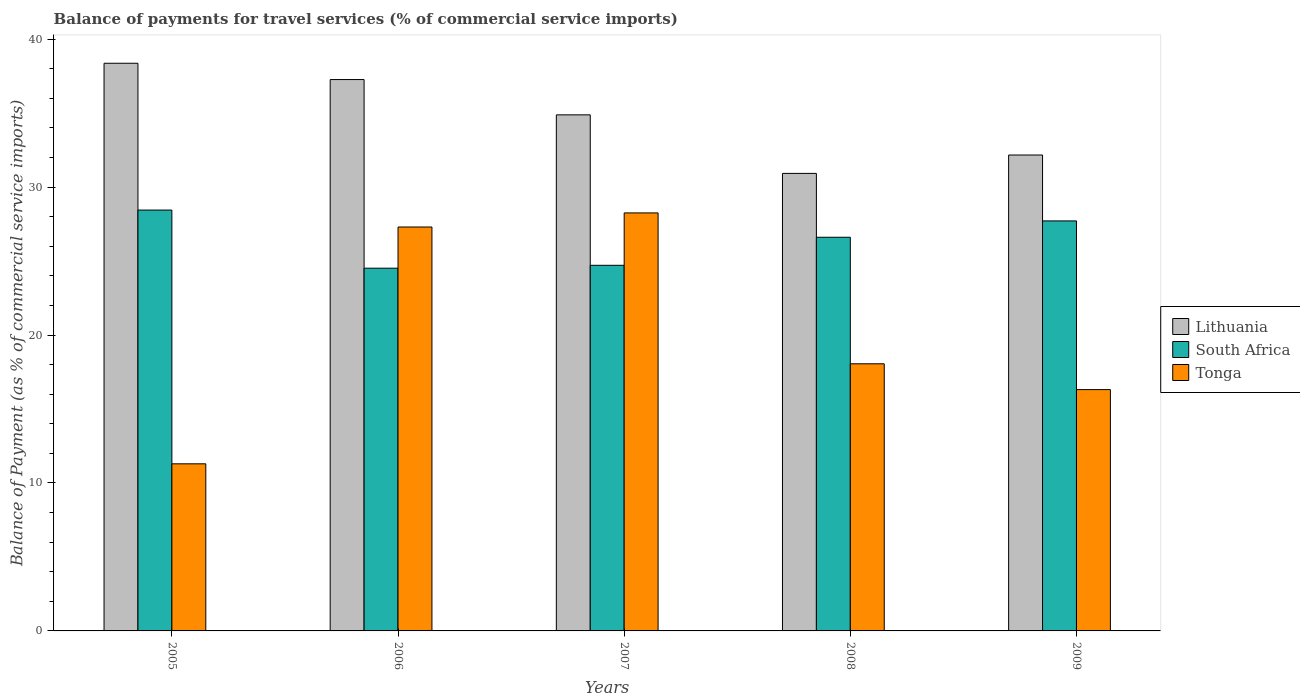How many different coloured bars are there?
Offer a very short reply. 3. How many groups of bars are there?
Make the answer very short. 5. How many bars are there on the 1st tick from the left?
Your response must be concise. 3. How many bars are there on the 4th tick from the right?
Your answer should be very brief. 3. What is the label of the 1st group of bars from the left?
Make the answer very short. 2005. In how many cases, is the number of bars for a given year not equal to the number of legend labels?
Make the answer very short. 0. What is the balance of payments for travel services in South Africa in 2005?
Offer a terse response. 28.45. Across all years, what is the maximum balance of payments for travel services in South Africa?
Offer a terse response. 28.45. Across all years, what is the minimum balance of payments for travel services in Lithuania?
Keep it short and to the point. 30.93. What is the total balance of payments for travel services in Lithuania in the graph?
Offer a terse response. 173.62. What is the difference between the balance of payments for travel services in Tonga in 2006 and that in 2008?
Your response must be concise. 9.25. What is the difference between the balance of payments for travel services in Lithuania in 2008 and the balance of payments for travel services in South Africa in 2005?
Offer a terse response. 2.48. What is the average balance of payments for travel services in Lithuania per year?
Provide a succinct answer. 34.72. In the year 2005, what is the difference between the balance of payments for travel services in South Africa and balance of payments for travel services in Lithuania?
Give a very brief answer. -9.92. In how many years, is the balance of payments for travel services in South Africa greater than 24 %?
Give a very brief answer. 5. What is the ratio of the balance of payments for travel services in Lithuania in 2005 to that in 2009?
Ensure brevity in your answer.  1.19. Is the balance of payments for travel services in Tonga in 2006 less than that in 2009?
Offer a very short reply. No. Is the difference between the balance of payments for travel services in South Africa in 2006 and 2007 greater than the difference between the balance of payments for travel services in Lithuania in 2006 and 2007?
Your answer should be very brief. No. What is the difference between the highest and the second highest balance of payments for travel services in Lithuania?
Give a very brief answer. 1.1. What is the difference between the highest and the lowest balance of payments for travel services in Tonga?
Your answer should be compact. 16.96. What does the 3rd bar from the left in 2008 represents?
Your answer should be very brief. Tonga. What does the 3rd bar from the right in 2009 represents?
Ensure brevity in your answer.  Lithuania. What is the difference between two consecutive major ticks on the Y-axis?
Your answer should be very brief. 10. What is the title of the graph?
Make the answer very short. Balance of payments for travel services (% of commercial service imports). Does "Saudi Arabia" appear as one of the legend labels in the graph?
Ensure brevity in your answer.  No. What is the label or title of the X-axis?
Give a very brief answer. Years. What is the label or title of the Y-axis?
Your answer should be very brief. Balance of Payment (as % of commercial service imports). What is the Balance of Payment (as % of commercial service imports) in Lithuania in 2005?
Keep it short and to the point. 38.37. What is the Balance of Payment (as % of commercial service imports) in South Africa in 2005?
Provide a short and direct response. 28.45. What is the Balance of Payment (as % of commercial service imports) in Tonga in 2005?
Your response must be concise. 11.29. What is the Balance of Payment (as % of commercial service imports) of Lithuania in 2006?
Offer a terse response. 37.27. What is the Balance of Payment (as % of commercial service imports) in South Africa in 2006?
Provide a succinct answer. 24.52. What is the Balance of Payment (as % of commercial service imports) in Tonga in 2006?
Make the answer very short. 27.3. What is the Balance of Payment (as % of commercial service imports) of Lithuania in 2007?
Offer a terse response. 34.88. What is the Balance of Payment (as % of commercial service imports) in South Africa in 2007?
Offer a terse response. 24.71. What is the Balance of Payment (as % of commercial service imports) in Tonga in 2007?
Give a very brief answer. 28.25. What is the Balance of Payment (as % of commercial service imports) in Lithuania in 2008?
Ensure brevity in your answer.  30.93. What is the Balance of Payment (as % of commercial service imports) in South Africa in 2008?
Provide a short and direct response. 26.61. What is the Balance of Payment (as % of commercial service imports) of Tonga in 2008?
Your answer should be very brief. 18.06. What is the Balance of Payment (as % of commercial service imports) of Lithuania in 2009?
Give a very brief answer. 32.17. What is the Balance of Payment (as % of commercial service imports) of South Africa in 2009?
Give a very brief answer. 27.71. What is the Balance of Payment (as % of commercial service imports) in Tonga in 2009?
Give a very brief answer. 16.31. Across all years, what is the maximum Balance of Payment (as % of commercial service imports) in Lithuania?
Offer a very short reply. 38.37. Across all years, what is the maximum Balance of Payment (as % of commercial service imports) in South Africa?
Your answer should be compact. 28.45. Across all years, what is the maximum Balance of Payment (as % of commercial service imports) of Tonga?
Your answer should be very brief. 28.25. Across all years, what is the minimum Balance of Payment (as % of commercial service imports) in Lithuania?
Your answer should be compact. 30.93. Across all years, what is the minimum Balance of Payment (as % of commercial service imports) in South Africa?
Keep it short and to the point. 24.52. Across all years, what is the minimum Balance of Payment (as % of commercial service imports) in Tonga?
Your answer should be very brief. 11.29. What is the total Balance of Payment (as % of commercial service imports) in Lithuania in the graph?
Your response must be concise. 173.62. What is the total Balance of Payment (as % of commercial service imports) in South Africa in the graph?
Give a very brief answer. 132. What is the total Balance of Payment (as % of commercial service imports) in Tonga in the graph?
Offer a terse response. 101.22. What is the difference between the Balance of Payment (as % of commercial service imports) in Lithuania in 2005 and that in 2006?
Your answer should be compact. 1.1. What is the difference between the Balance of Payment (as % of commercial service imports) in South Africa in 2005 and that in 2006?
Keep it short and to the point. 3.93. What is the difference between the Balance of Payment (as % of commercial service imports) of Tonga in 2005 and that in 2006?
Provide a short and direct response. -16.01. What is the difference between the Balance of Payment (as % of commercial service imports) in Lithuania in 2005 and that in 2007?
Offer a terse response. 3.49. What is the difference between the Balance of Payment (as % of commercial service imports) of South Africa in 2005 and that in 2007?
Provide a short and direct response. 3.73. What is the difference between the Balance of Payment (as % of commercial service imports) in Tonga in 2005 and that in 2007?
Provide a succinct answer. -16.96. What is the difference between the Balance of Payment (as % of commercial service imports) of Lithuania in 2005 and that in 2008?
Ensure brevity in your answer.  7.44. What is the difference between the Balance of Payment (as % of commercial service imports) of South Africa in 2005 and that in 2008?
Offer a terse response. 1.84. What is the difference between the Balance of Payment (as % of commercial service imports) in Tonga in 2005 and that in 2008?
Offer a terse response. -6.76. What is the difference between the Balance of Payment (as % of commercial service imports) of Lithuania in 2005 and that in 2009?
Offer a terse response. 6.2. What is the difference between the Balance of Payment (as % of commercial service imports) in South Africa in 2005 and that in 2009?
Provide a succinct answer. 0.73. What is the difference between the Balance of Payment (as % of commercial service imports) of Tonga in 2005 and that in 2009?
Provide a short and direct response. -5.02. What is the difference between the Balance of Payment (as % of commercial service imports) of Lithuania in 2006 and that in 2007?
Offer a very short reply. 2.39. What is the difference between the Balance of Payment (as % of commercial service imports) of South Africa in 2006 and that in 2007?
Provide a short and direct response. -0.2. What is the difference between the Balance of Payment (as % of commercial service imports) of Tonga in 2006 and that in 2007?
Provide a succinct answer. -0.95. What is the difference between the Balance of Payment (as % of commercial service imports) of Lithuania in 2006 and that in 2008?
Provide a short and direct response. 6.34. What is the difference between the Balance of Payment (as % of commercial service imports) in South Africa in 2006 and that in 2008?
Provide a short and direct response. -2.09. What is the difference between the Balance of Payment (as % of commercial service imports) of Tonga in 2006 and that in 2008?
Your answer should be compact. 9.25. What is the difference between the Balance of Payment (as % of commercial service imports) of Lithuania in 2006 and that in 2009?
Make the answer very short. 5.1. What is the difference between the Balance of Payment (as % of commercial service imports) in South Africa in 2006 and that in 2009?
Your answer should be very brief. -3.2. What is the difference between the Balance of Payment (as % of commercial service imports) of Tonga in 2006 and that in 2009?
Offer a very short reply. 10.99. What is the difference between the Balance of Payment (as % of commercial service imports) in Lithuania in 2007 and that in 2008?
Make the answer very short. 3.96. What is the difference between the Balance of Payment (as % of commercial service imports) of South Africa in 2007 and that in 2008?
Your response must be concise. -1.9. What is the difference between the Balance of Payment (as % of commercial service imports) in Tonga in 2007 and that in 2008?
Offer a very short reply. 10.2. What is the difference between the Balance of Payment (as % of commercial service imports) in Lithuania in 2007 and that in 2009?
Give a very brief answer. 2.71. What is the difference between the Balance of Payment (as % of commercial service imports) of South Africa in 2007 and that in 2009?
Offer a terse response. -3. What is the difference between the Balance of Payment (as % of commercial service imports) of Tonga in 2007 and that in 2009?
Your answer should be compact. 11.94. What is the difference between the Balance of Payment (as % of commercial service imports) of Lithuania in 2008 and that in 2009?
Provide a succinct answer. -1.24. What is the difference between the Balance of Payment (as % of commercial service imports) in South Africa in 2008 and that in 2009?
Provide a succinct answer. -1.1. What is the difference between the Balance of Payment (as % of commercial service imports) in Tonga in 2008 and that in 2009?
Give a very brief answer. 1.74. What is the difference between the Balance of Payment (as % of commercial service imports) of Lithuania in 2005 and the Balance of Payment (as % of commercial service imports) of South Africa in 2006?
Make the answer very short. 13.85. What is the difference between the Balance of Payment (as % of commercial service imports) of Lithuania in 2005 and the Balance of Payment (as % of commercial service imports) of Tonga in 2006?
Your answer should be very brief. 11.07. What is the difference between the Balance of Payment (as % of commercial service imports) of South Africa in 2005 and the Balance of Payment (as % of commercial service imports) of Tonga in 2006?
Offer a very short reply. 1.15. What is the difference between the Balance of Payment (as % of commercial service imports) in Lithuania in 2005 and the Balance of Payment (as % of commercial service imports) in South Africa in 2007?
Make the answer very short. 13.66. What is the difference between the Balance of Payment (as % of commercial service imports) of Lithuania in 2005 and the Balance of Payment (as % of commercial service imports) of Tonga in 2007?
Offer a terse response. 10.12. What is the difference between the Balance of Payment (as % of commercial service imports) in South Africa in 2005 and the Balance of Payment (as % of commercial service imports) in Tonga in 2007?
Offer a terse response. 0.19. What is the difference between the Balance of Payment (as % of commercial service imports) in Lithuania in 2005 and the Balance of Payment (as % of commercial service imports) in South Africa in 2008?
Ensure brevity in your answer.  11.76. What is the difference between the Balance of Payment (as % of commercial service imports) of Lithuania in 2005 and the Balance of Payment (as % of commercial service imports) of Tonga in 2008?
Ensure brevity in your answer.  20.31. What is the difference between the Balance of Payment (as % of commercial service imports) of South Africa in 2005 and the Balance of Payment (as % of commercial service imports) of Tonga in 2008?
Offer a terse response. 10.39. What is the difference between the Balance of Payment (as % of commercial service imports) in Lithuania in 2005 and the Balance of Payment (as % of commercial service imports) in South Africa in 2009?
Give a very brief answer. 10.66. What is the difference between the Balance of Payment (as % of commercial service imports) in Lithuania in 2005 and the Balance of Payment (as % of commercial service imports) in Tonga in 2009?
Make the answer very short. 22.06. What is the difference between the Balance of Payment (as % of commercial service imports) in South Africa in 2005 and the Balance of Payment (as % of commercial service imports) in Tonga in 2009?
Ensure brevity in your answer.  12.14. What is the difference between the Balance of Payment (as % of commercial service imports) in Lithuania in 2006 and the Balance of Payment (as % of commercial service imports) in South Africa in 2007?
Your response must be concise. 12.56. What is the difference between the Balance of Payment (as % of commercial service imports) of Lithuania in 2006 and the Balance of Payment (as % of commercial service imports) of Tonga in 2007?
Ensure brevity in your answer.  9.01. What is the difference between the Balance of Payment (as % of commercial service imports) in South Africa in 2006 and the Balance of Payment (as % of commercial service imports) in Tonga in 2007?
Keep it short and to the point. -3.74. What is the difference between the Balance of Payment (as % of commercial service imports) of Lithuania in 2006 and the Balance of Payment (as % of commercial service imports) of South Africa in 2008?
Offer a very short reply. 10.66. What is the difference between the Balance of Payment (as % of commercial service imports) in Lithuania in 2006 and the Balance of Payment (as % of commercial service imports) in Tonga in 2008?
Give a very brief answer. 19.21. What is the difference between the Balance of Payment (as % of commercial service imports) of South Africa in 2006 and the Balance of Payment (as % of commercial service imports) of Tonga in 2008?
Offer a terse response. 6.46. What is the difference between the Balance of Payment (as % of commercial service imports) of Lithuania in 2006 and the Balance of Payment (as % of commercial service imports) of South Africa in 2009?
Ensure brevity in your answer.  9.56. What is the difference between the Balance of Payment (as % of commercial service imports) in Lithuania in 2006 and the Balance of Payment (as % of commercial service imports) in Tonga in 2009?
Offer a very short reply. 20.96. What is the difference between the Balance of Payment (as % of commercial service imports) of South Africa in 2006 and the Balance of Payment (as % of commercial service imports) of Tonga in 2009?
Give a very brief answer. 8.21. What is the difference between the Balance of Payment (as % of commercial service imports) in Lithuania in 2007 and the Balance of Payment (as % of commercial service imports) in South Africa in 2008?
Your answer should be compact. 8.27. What is the difference between the Balance of Payment (as % of commercial service imports) in Lithuania in 2007 and the Balance of Payment (as % of commercial service imports) in Tonga in 2008?
Keep it short and to the point. 16.83. What is the difference between the Balance of Payment (as % of commercial service imports) in South Africa in 2007 and the Balance of Payment (as % of commercial service imports) in Tonga in 2008?
Make the answer very short. 6.66. What is the difference between the Balance of Payment (as % of commercial service imports) in Lithuania in 2007 and the Balance of Payment (as % of commercial service imports) in South Africa in 2009?
Offer a very short reply. 7.17. What is the difference between the Balance of Payment (as % of commercial service imports) in Lithuania in 2007 and the Balance of Payment (as % of commercial service imports) in Tonga in 2009?
Keep it short and to the point. 18.57. What is the difference between the Balance of Payment (as % of commercial service imports) in South Africa in 2007 and the Balance of Payment (as % of commercial service imports) in Tonga in 2009?
Give a very brief answer. 8.4. What is the difference between the Balance of Payment (as % of commercial service imports) in Lithuania in 2008 and the Balance of Payment (as % of commercial service imports) in South Africa in 2009?
Keep it short and to the point. 3.21. What is the difference between the Balance of Payment (as % of commercial service imports) of Lithuania in 2008 and the Balance of Payment (as % of commercial service imports) of Tonga in 2009?
Offer a very short reply. 14.61. What is the difference between the Balance of Payment (as % of commercial service imports) of South Africa in 2008 and the Balance of Payment (as % of commercial service imports) of Tonga in 2009?
Offer a very short reply. 10.3. What is the average Balance of Payment (as % of commercial service imports) of Lithuania per year?
Offer a terse response. 34.72. What is the average Balance of Payment (as % of commercial service imports) in South Africa per year?
Ensure brevity in your answer.  26.4. What is the average Balance of Payment (as % of commercial service imports) of Tonga per year?
Your answer should be compact. 20.24. In the year 2005, what is the difference between the Balance of Payment (as % of commercial service imports) in Lithuania and Balance of Payment (as % of commercial service imports) in South Africa?
Your answer should be very brief. 9.92. In the year 2005, what is the difference between the Balance of Payment (as % of commercial service imports) in Lithuania and Balance of Payment (as % of commercial service imports) in Tonga?
Ensure brevity in your answer.  27.08. In the year 2005, what is the difference between the Balance of Payment (as % of commercial service imports) in South Africa and Balance of Payment (as % of commercial service imports) in Tonga?
Your response must be concise. 17.15. In the year 2006, what is the difference between the Balance of Payment (as % of commercial service imports) of Lithuania and Balance of Payment (as % of commercial service imports) of South Africa?
Give a very brief answer. 12.75. In the year 2006, what is the difference between the Balance of Payment (as % of commercial service imports) in Lithuania and Balance of Payment (as % of commercial service imports) in Tonga?
Give a very brief answer. 9.97. In the year 2006, what is the difference between the Balance of Payment (as % of commercial service imports) in South Africa and Balance of Payment (as % of commercial service imports) in Tonga?
Provide a succinct answer. -2.78. In the year 2007, what is the difference between the Balance of Payment (as % of commercial service imports) in Lithuania and Balance of Payment (as % of commercial service imports) in South Africa?
Offer a very short reply. 10.17. In the year 2007, what is the difference between the Balance of Payment (as % of commercial service imports) in Lithuania and Balance of Payment (as % of commercial service imports) in Tonga?
Give a very brief answer. 6.63. In the year 2007, what is the difference between the Balance of Payment (as % of commercial service imports) in South Africa and Balance of Payment (as % of commercial service imports) in Tonga?
Ensure brevity in your answer.  -3.54. In the year 2008, what is the difference between the Balance of Payment (as % of commercial service imports) of Lithuania and Balance of Payment (as % of commercial service imports) of South Africa?
Your answer should be very brief. 4.32. In the year 2008, what is the difference between the Balance of Payment (as % of commercial service imports) of Lithuania and Balance of Payment (as % of commercial service imports) of Tonga?
Ensure brevity in your answer.  12.87. In the year 2008, what is the difference between the Balance of Payment (as % of commercial service imports) of South Africa and Balance of Payment (as % of commercial service imports) of Tonga?
Offer a terse response. 8.55. In the year 2009, what is the difference between the Balance of Payment (as % of commercial service imports) of Lithuania and Balance of Payment (as % of commercial service imports) of South Africa?
Your answer should be very brief. 4.45. In the year 2009, what is the difference between the Balance of Payment (as % of commercial service imports) in Lithuania and Balance of Payment (as % of commercial service imports) in Tonga?
Your answer should be very brief. 15.86. In the year 2009, what is the difference between the Balance of Payment (as % of commercial service imports) in South Africa and Balance of Payment (as % of commercial service imports) in Tonga?
Give a very brief answer. 11.4. What is the ratio of the Balance of Payment (as % of commercial service imports) of Lithuania in 2005 to that in 2006?
Keep it short and to the point. 1.03. What is the ratio of the Balance of Payment (as % of commercial service imports) of South Africa in 2005 to that in 2006?
Your answer should be compact. 1.16. What is the ratio of the Balance of Payment (as % of commercial service imports) of Tonga in 2005 to that in 2006?
Your answer should be compact. 0.41. What is the ratio of the Balance of Payment (as % of commercial service imports) of Lithuania in 2005 to that in 2007?
Your response must be concise. 1.1. What is the ratio of the Balance of Payment (as % of commercial service imports) of South Africa in 2005 to that in 2007?
Your answer should be compact. 1.15. What is the ratio of the Balance of Payment (as % of commercial service imports) of Tonga in 2005 to that in 2007?
Your answer should be compact. 0.4. What is the ratio of the Balance of Payment (as % of commercial service imports) in Lithuania in 2005 to that in 2008?
Your response must be concise. 1.24. What is the ratio of the Balance of Payment (as % of commercial service imports) in South Africa in 2005 to that in 2008?
Your response must be concise. 1.07. What is the ratio of the Balance of Payment (as % of commercial service imports) of Tonga in 2005 to that in 2008?
Provide a succinct answer. 0.63. What is the ratio of the Balance of Payment (as % of commercial service imports) of Lithuania in 2005 to that in 2009?
Your answer should be very brief. 1.19. What is the ratio of the Balance of Payment (as % of commercial service imports) in South Africa in 2005 to that in 2009?
Keep it short and to the point. 1.03. What is the ratio of the Balance of Payment (as % of commercial service imports) in Tonga in 2005 to that in 2009?
Make the answer very short. 0.69. What is the ratio of the Balance of Payment (as % of commercial service imports) in Lithuania in 2006 to that in 2007?
Your response must be concise. 1.07. What is the ratio of the Balance of Payment (as % of commercial service imports) of Tonga in 2006 to that in 2007?
Give a very brief answer. 0.97. What is the ratio of the Balance of Payment (as % of commercial service imports) of Lithuania in 2006 to that in 2008?
Provide a succinct answer. 1.21. What is the ratio of the Balance of Payment (as % of commercial service imports) in South Africa in 2006 to that in 2008?
Offer a terse response. 0.92. What is the ratio of the Balance of Payment (as % of commercial service imports) of Tonga in 2006 to that in 2008?
Provide a succinct answer. 1.51. What is the ratio of the Balance of Payment (as % of commercial service imports) of Lithuania in 2006 to that in 2009?
Keep it short and to the point. 1.16. What is the ratio of the Balance of Payment (as % of commercial service imports) in South Africa in 2006 to that in 2009?
Provide a succinct answer. 0.88. What is the ratio of the Balance of Payment (as % of commercial service imports) of Tonga in 2006 to that in 2009?
Your answer should be compact. 1.67. What is the ratio of the Balance of Payment (as % of commercial service imports) in Lithuania in 2007 to that in 2008?
Your response must be concise. 1.13. What is the ratio of the Balance of Payment (as % of commercial service imports) of South Africa in 2007 to that in 2008?
Your answer should be very brief. 0.93. What is the ratio of the Balance of Payment (as % of commercial service imports) of Tonga in 2007 to that in 2008?
Your answer should be compact. 1.56. What is the ratio of the Balance of Payment (as % of commercial service imports) of Lithuania in 2007 to that in 2009?
Your answer should be very brief. 1.08. What is the ratio of the Balance of Payment (as % of commercial service imports) of South Africa in 2007 to that in 2009?
Offer a terse response. 0.89. What is the ratio of the Balance of Payment (as % of commercial service imports) in Tonga in 2007 to that in 2009?
Provide a succinct answer. 1.73. What is the ratio of the Balance of Payment (as % of commercial service imports) of Lithuania in 2008 to that in 2009?
Your answer should be very brief. 0.96. What is the ratio of the Balance of Payment (as % of commercial service imports) of South Africa in 2008 to that in 2009?
Provide a succinct answer. 0.96. What is the ratio of the Balance of Payment (as % of commercial service imports) of Tonga in 2008 to that in 2009?
Provide a short and direct response. 1.11. What is the difference between the highest and the second highest Balance of Payment (as % of commercial service imports) of Lithuania?
Provide a short and direct response. 1.1. What is the difference between the highest and the second highest Balance of Payment (as % of commercial service imports) in South Africa?
Your answer should be compact. 0.73. What is the difference between the highest and the second highest Balance of Payment (as % of commercial service imports) in Tonga?
Offer a very short reply. 0.95. What is the difference between the highest and the lowest Balance of Payment (as % of commercial service imports) of Lithuania?
Make the answer very short. 7.44. What is the difference between the highest and the lowest Balance of Payment (as % of commercial service imports) in South Africa?
Ensure brevity in your answer.  3.93. What is the difference between the highest and the lowest Balance of Payment (as % of commercial service imports) of Tonga?
Keep it short and to the point. 16.96. 